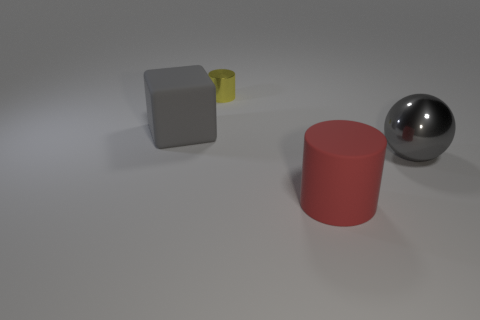The cylinder that is the same size as the shiny sphere is what color?
Your response must be concise. Red. There is a large gray thing that is to the right of the big matte cylinder; what is its material?
Give a very brief answer. Metal. The object that is behind the gray metallic thing and in front of the small cylinder is made of what material?
Give a very brief answer. Rubber. There is a gray cube that is behind the metallic ball; is its size the same as the yellow shiny thing?
Your answer should be compact. No. What shape is the gray rubber thing?
Make the answer very short. Cube. How many other things are the same shape as the big gray shiny object?
Your answer should be very brief. 0. What number of objects are behind the red object and in front of the large gray rubber thing?
Your answer should be very brief. 1. What is the color of the big rubber cylinder?
Provide a short and direct response. Red. Is there a thing that has the same material as the gray cube?
Keep it short and to the point. Yes. There is a rubber object that is behind the matte object in front of the large sphere; are there any big cylinders that are in front of it?
Give a very brief answer. Yes. 